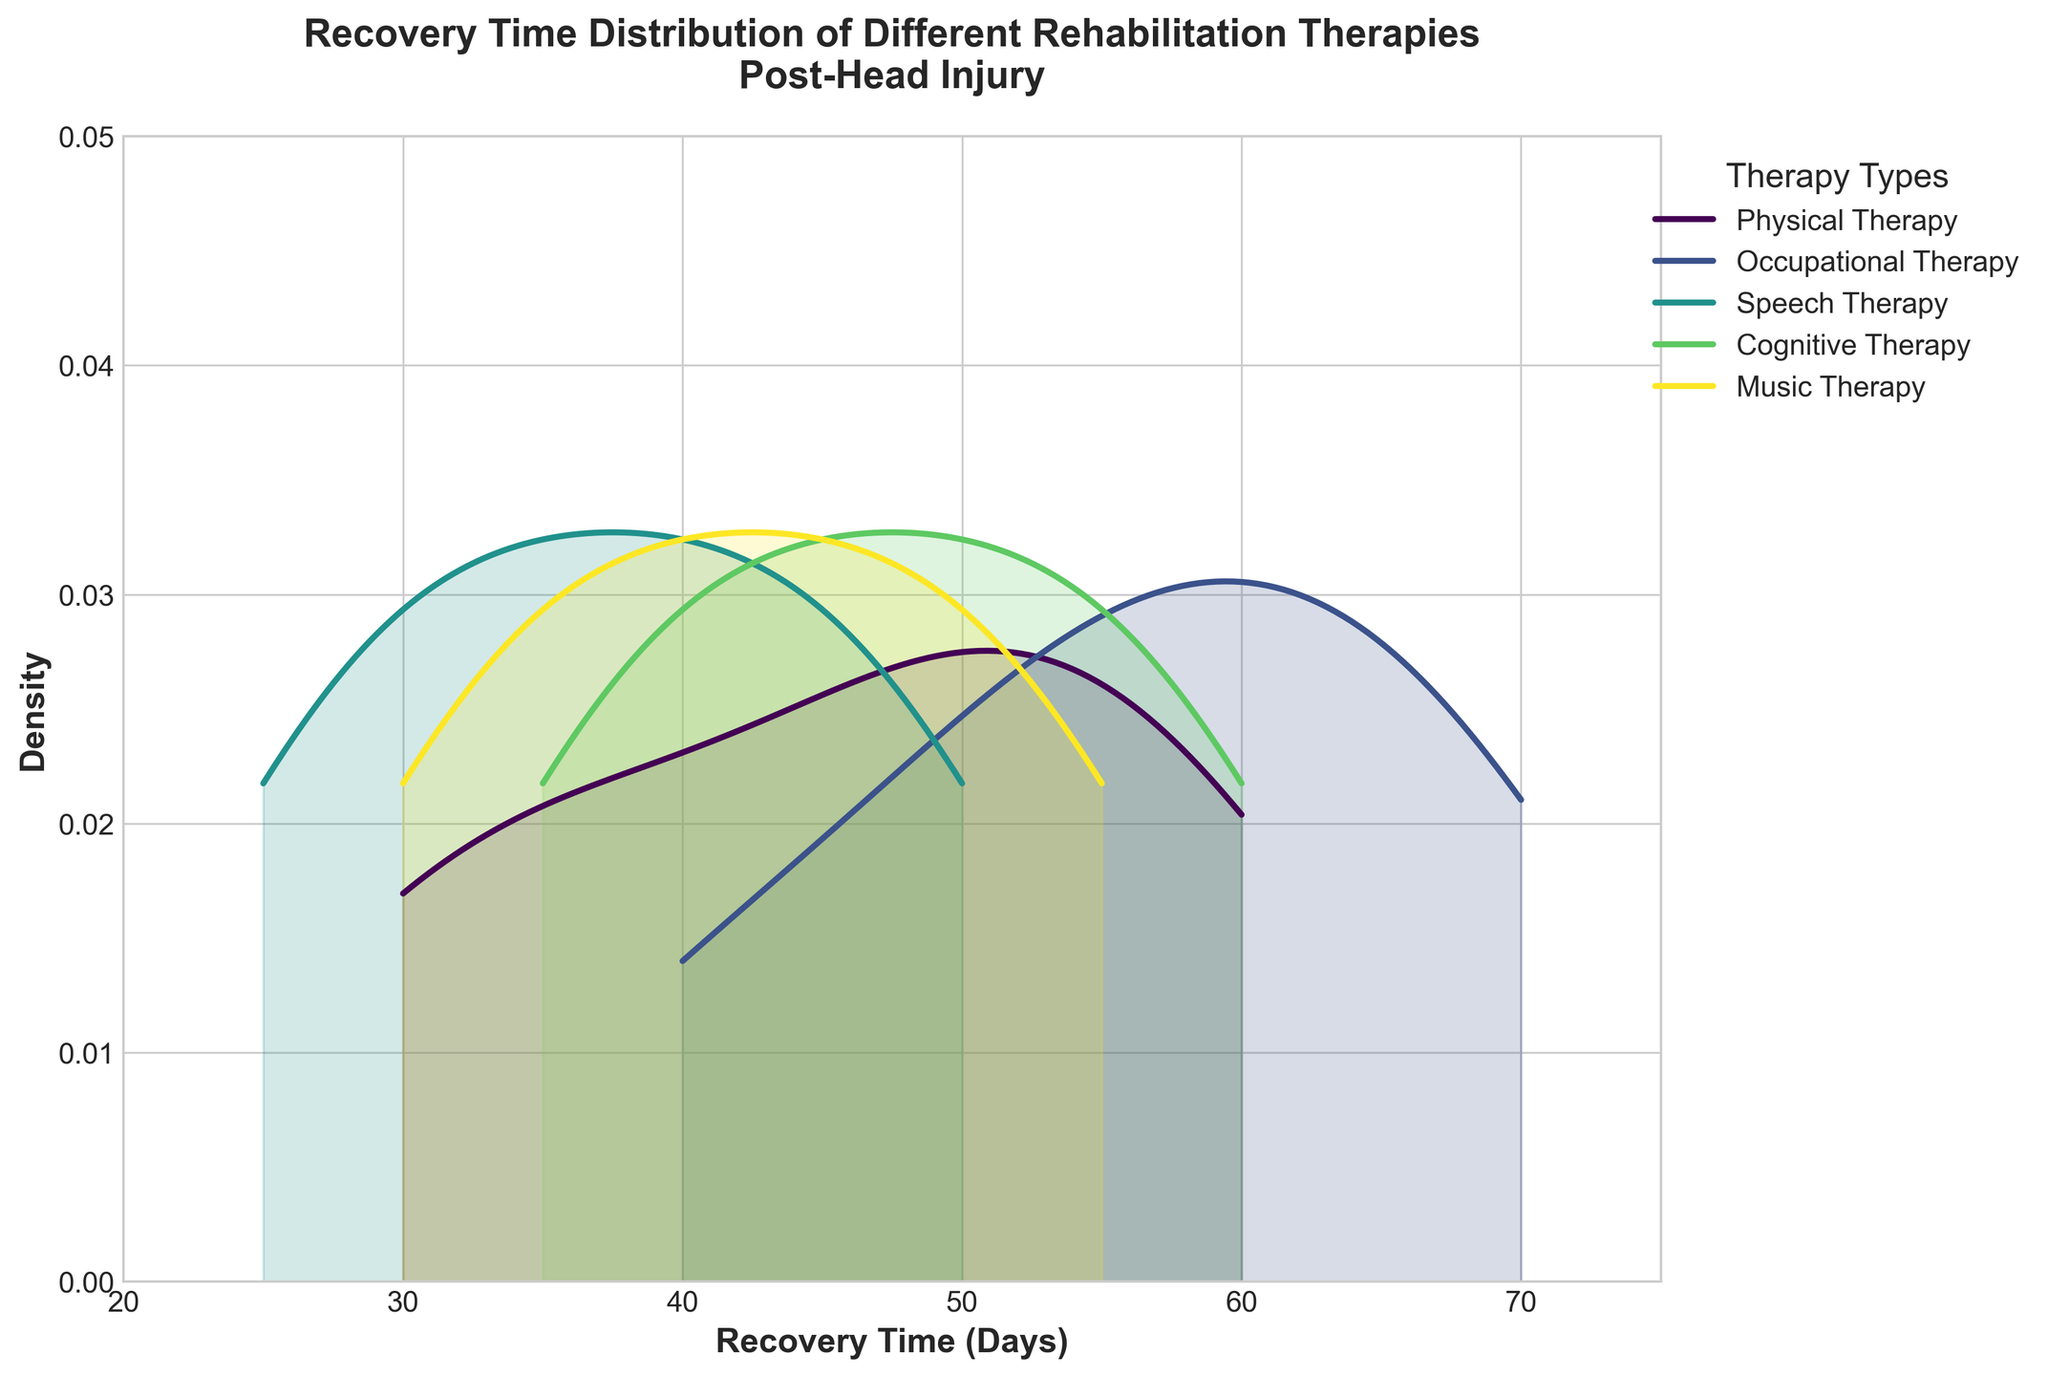What is the title of the figure? The title of the figure is located in a prominent position at the top and is in larger, bold text.
Answer: Recovery Time Distribution of Different Rehabilitation Therapies Post-Head Injury How many different therapy types are represented in the plot? Count the number of unique lines or shaded areas in different colors, each representing a different therapy type, and also refer to the legend which labels them.
Answer: 5 Which therapy has the peak density in the shortest number of recovery days? Identify which therapy’s density curve reaches its highest point at the leftmost position on the x-axis, indicating the shortest recovery time.
Answer: Speech Therapy What is the approximate recovery time where Physical Therapy has its maximum density? Look at the peak of the density curve for Physical Therapy and identify the corresponding recovery time on the x-axis.
Answer: About 45 days How does the density curve of Cognitive Therapy compare with Occupational Therapy in terms of recovery time? Compare the density curves of Cognitive Therapy and Occupational Therapy, focusing on their shapes, peaks, and spread along the x-axis recovery time.
Answer: Cognitive Therapy has a narrower peak around 45-50 days, whereas Occupational Therapy is more spread out across 50-70 days Which therapy type shows the widest diversity in recovery days? Look for the therapy type whose density curve extends over the widest range of recovery days on the x-axis.
Answer: Occupational Therapy At approximately 30 days, which two therapies have noticeable densities? Identify the densities at the 30-day mark on the x-axis and see which therapies have a visible density curve at this point.
Answer: Physical Therapy and Speech Therapy If you had to choose a therapy to minimize recovery time, based on the plot, which one would you select? Look for the therapy with the density curve peaking at the lowest recovery times, and thus would likely result in faster recovery.
Answer: Speech Therapy What is the approximate range of recovery times for Music Therapy? Describe the interval on the x-axis where the density curve for Music Therapy is significant, or where it is filled under it.
Answer: 30-55 days Does any therapy show a density peak beyond 60 days? Check if any of the density curves reach their highest value or significant density beyond the 60-day mark on the x-axis.
Answer: Occupational Therapy 